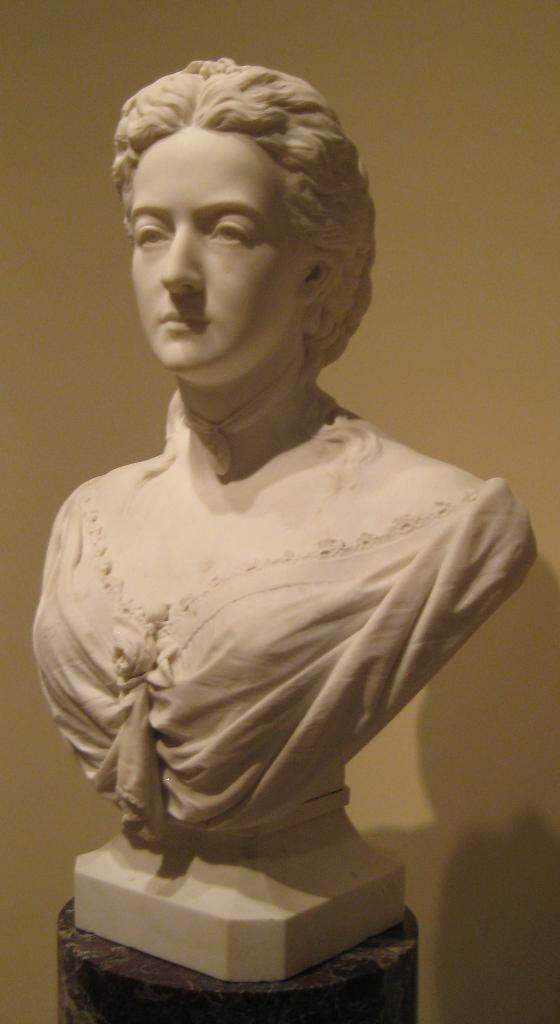What is the main subject of the image? There is a sculpture in the image. Can you describe the setting of the image? There is a wall in the background of the image. What type of wing is attached to the sculpture in the image? There is no wing attached to the sculpture in the image. What sign can be seen on the wall in the image? There is no sign visible on the wall in the image. 